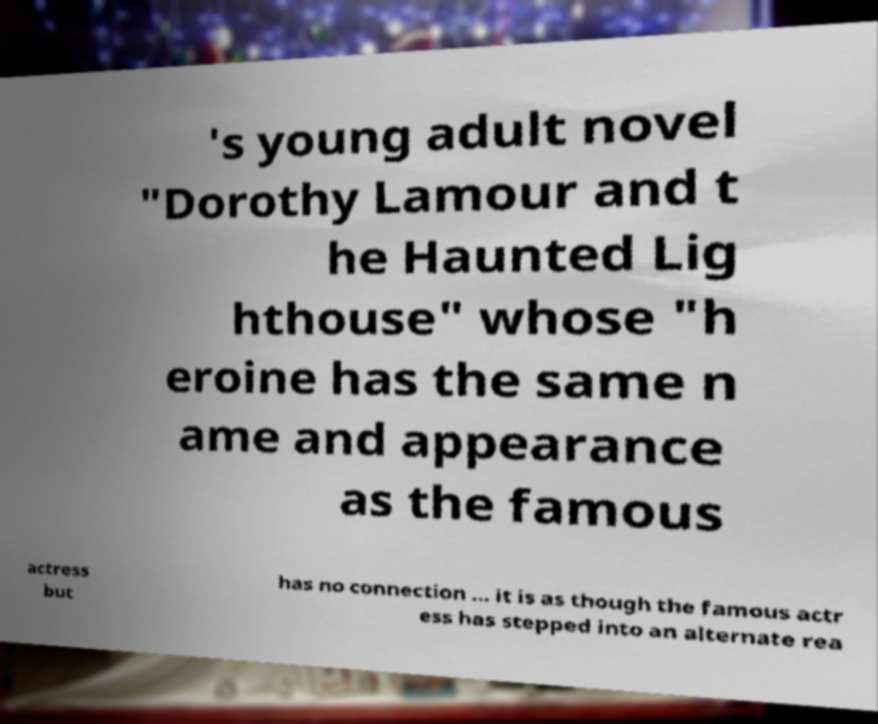Please identify and transcribe the text found in this image. 's young adult novel "Dorothy Lamour and t he Haunted Lig hthouse" whose "h eroine has the same n ame and appearance as the famous actress but has no connection ... it is as though the famous actr ess has stepped into an alternate rea 